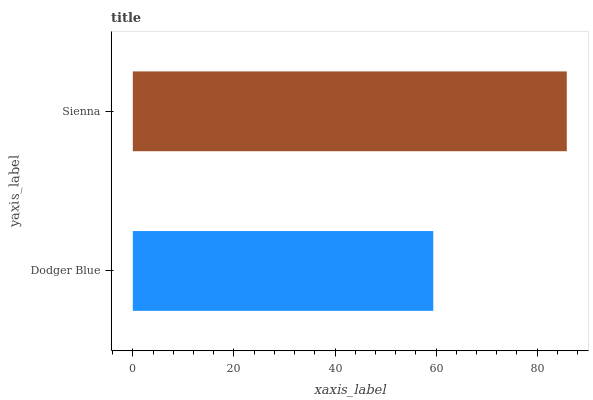Is Dodger Blue the minimum?
Answer yes or no. Yes. Is Sienna the maximum?
Answer yes or no. Yes. Is Sienna the minimum?
Answer yes or no. No. Is Sienna greater than Dodger Blue?
Answer yes or no. Yes. Is Dodger Blue less than Sienna?
Answer yes or no. Yes. Is Dodger Blue greater than Sienna?
Answer yes or no. No. Is Sienna less than Dodger Blue?
Answer yes or no. No. Is Sienna the high median?
Answer yes or no. Yes. Is Dodger Blue the low median?
Answer yes or no. Yes. Is Dodger Blue the high median?
Answer yes or no. No. Is Sienna the low median?
Answer yes or no. No. 